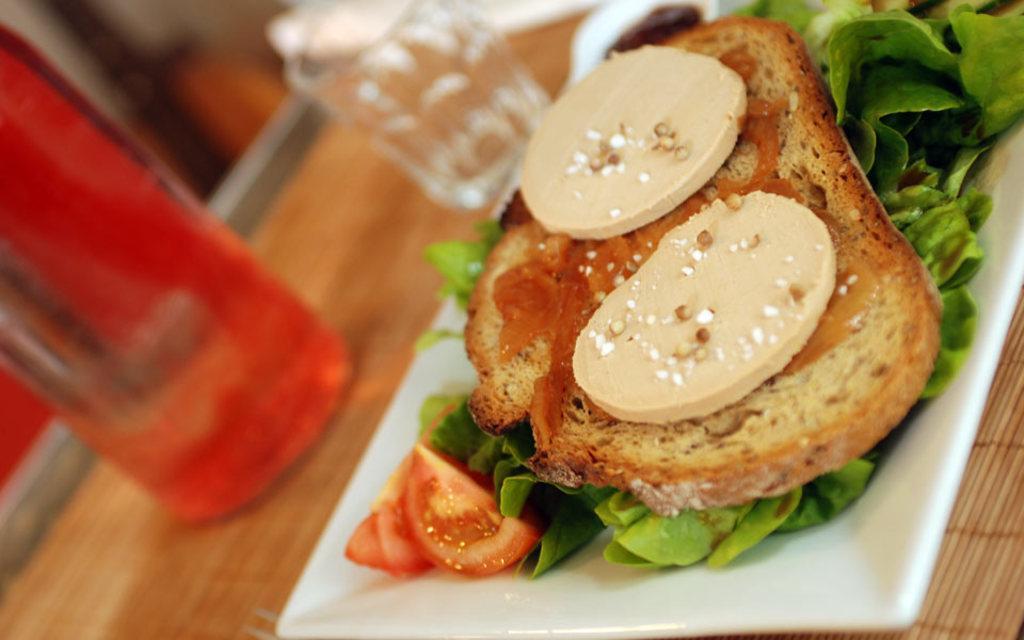Could you give a brief overview of what you see in this image? In this picture we can see some eatable item placed in a plate, which is placed on the table, on the table we can see bottle, glass. 